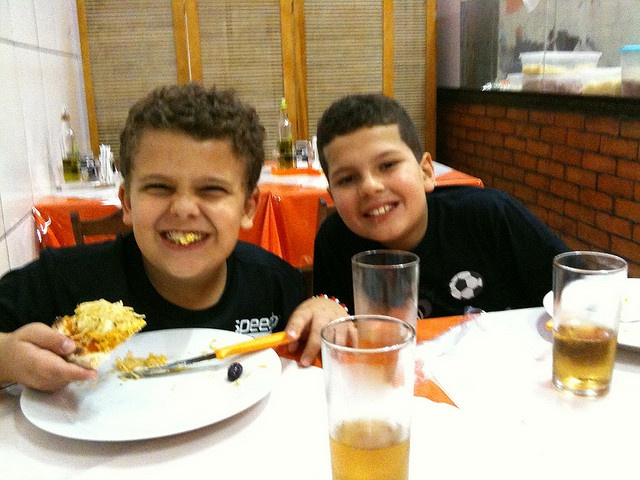Describe the objects in this image and their specific colors. I can see dining table in lightgray, ivory, tan, and darkgray tones, people in lightgray, black, tan, brown, and maroon tones, people in lightgray, black, tan, brown, and maroon tones, cup in lightgray, ivory, tan, and orange tones, and cup in lightgray, ivory, tan, maroon, and gray tones in this image. 